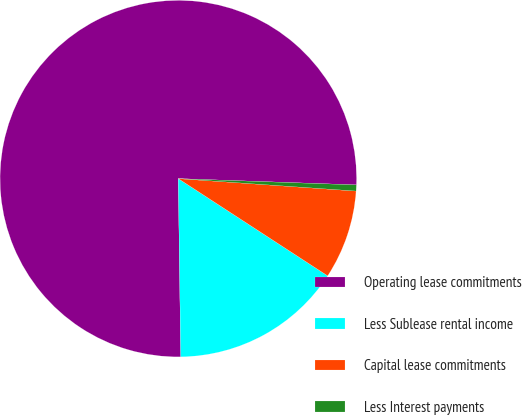Convert chart. <chart><loc_0><loc_0><loc_500><loc_500><pie_chart><fcel>Operating lease commitments<fcel>Less Sublease rental income<fcel>Capital lease commitments<fcel>Less Interest payments<nl><fcel>75.78%<fcel>15.6%<fcel>8.07%<fcel>0.55%<nl></chart> 